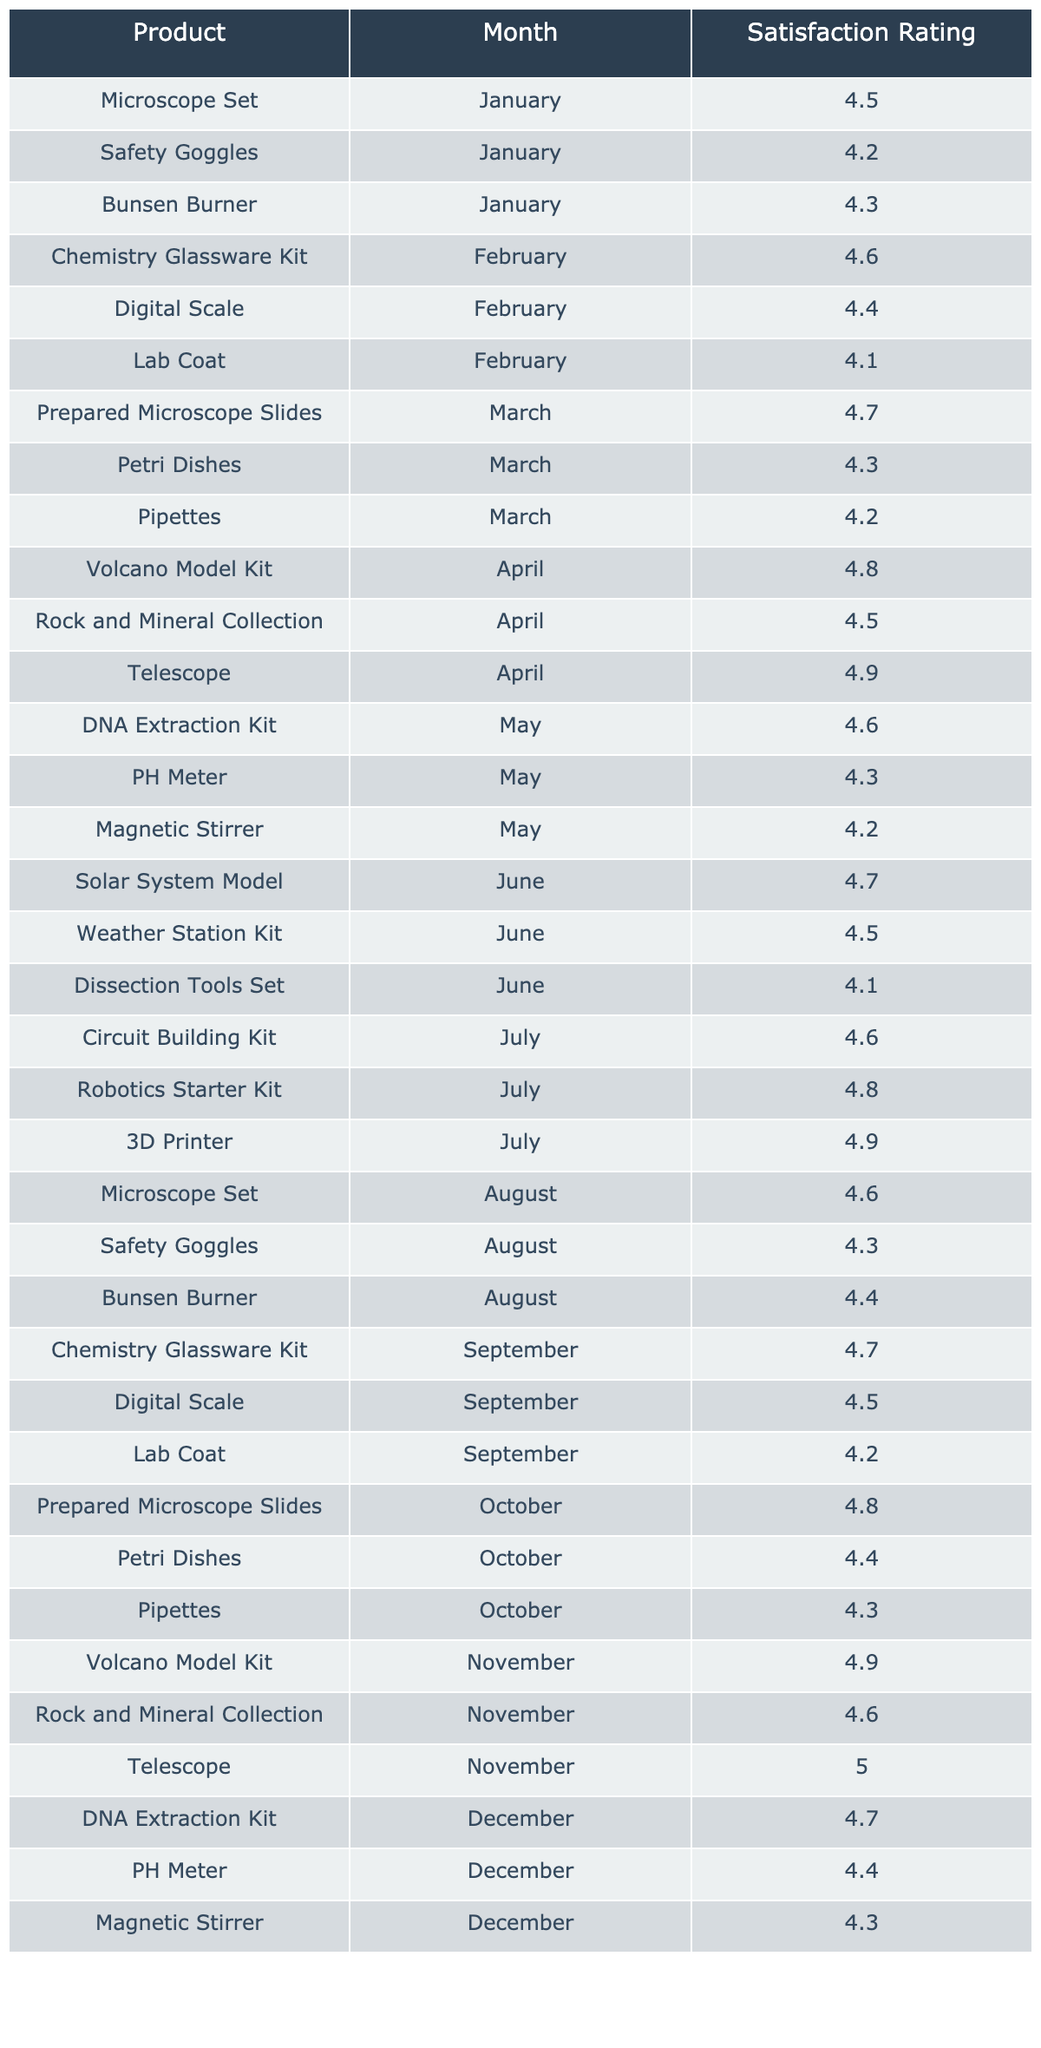What is the satisfaction rating for the Telescope in November? The table shows the satisfaction rating for the Telescope specifically in November as indicated in the corresponding row. The rating is listed as 5.0.
Answer: 5.0 Which product had the highest satisfaction rating in April? In the month of April, the satisfaction ratings for the products were 4.8 for Volcano Model Kit, 4.5 for Rock and Mineral Collection, and 4.9 for Telescope. The highest rating among these is 4.9 for the Telescope.
Answer: 4.9 What is the average satisfaction rating for the Chemistry Glassware Kit over the year? The ratings for the Chemistry Glassware Kit are 4.6 in February and 4.7 in September. Adding these gives 4.6 + 4.7 = 9.3, and dividing by 2 (since there are two ratings) gives an average of 4.65.
Answer: 4.65 Did the Safety Goggles receive a satisfaction rating of 4.5 at any point in the year? The table shows the ratings for Safety Goggles as 4.2 in January, 4.3 in August, and does not show a 4.5 rating. Therefore, it is true that Safety Goggles did not receive a rating of 4.5.
Answer: No What is the difference between the highest rated product and the lowest rated product for the entire year? The highest rating overall is 5.0 for the Telescope in November, and the lowest rating is 4.1 for the Lab Coat in February and June. The difference is 5.0 - 4.1 = 0.9.
Answer: 0.9 Which month had the most products rated above 4.5? By reviewing the ratings by month, we find that April had 3 products rated above 4.5 (Volcano Model Kit, Rock and Mineral Collection, and Telescope). Other months had fewer. Hence, April had the most products rated above 4.5.
Answer: April What was the average satisfaction rating for the Digital Scale throughout the year? The Digital Scale had ratings of 4.4 in February and 4.5 in September. Adding these ratings gives 4.4 + 4.5 = 8.9, and calculating the average by dividing by 2 yields 4.45.
Answer: 4.45 Is there any month where all products had a satisfaction rating below 4.5? By examining each month, we notice that in June, the Dissection Tools Set rated 4.1, which is below 4.5, while other products also have ratings below 4.5. Therefore, June is the month with products rated below 4.5.
Answer: Yes Which product consistently received ratings at or above 4.5 in all of its appearances? The Telescope appears in April with a rating of 4.9 and November with a rating of 5.0, both at or above 4.5. Therefore, the Telescope consistently received high ratings.
Answer: Telescope How many products received a satisfaction rating of 4.6 in total throughout the year? By checking the table, the products that received a 4.6 are the Chemistry Glassware Kit (February), DNA Extraction Kit (May), Circuit Building Kit (July), Microscope Set (August), and the Volcano Model Kit (November), totaling 5 products.
Answer: 5 